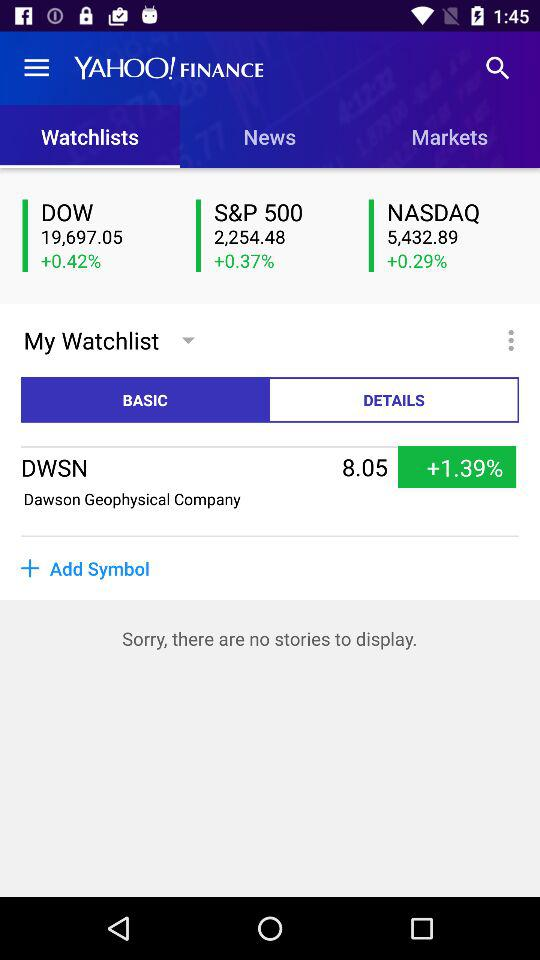What is the application name? The application name is "YAHOO! FINANCE". 